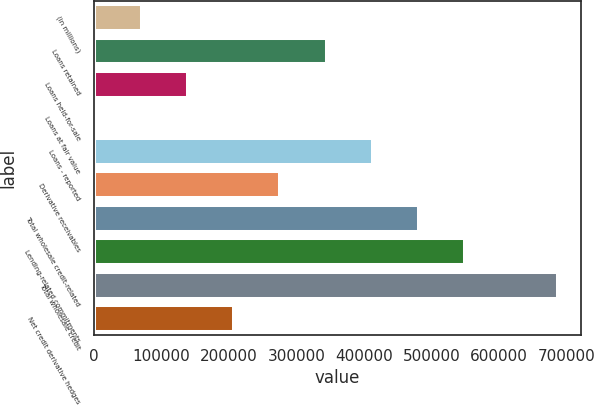Convert chart to OTSL. <chart><loc_0><loc_0><loc_500><loc_500><bar_chart><fcel>(in millions)<fcel>Loans retained<fcel>Loans held-for-sale<fcel>Loans at fair value<fcel>Loans - reported<fcel>Derivative receivables<fcel>Total wholesale credit-related<fcel>Lending-related commitments<fcel>Total wholesale credit<fcel>Net credit derivative hedges<nl><fcel>70490.9<fcel>344550<fcel>139006<fcel>1976<fcel>413065<fcel>276036<fcel>481580<fcel>550095<fcel>687125<fcel>207521<nl></chart> 